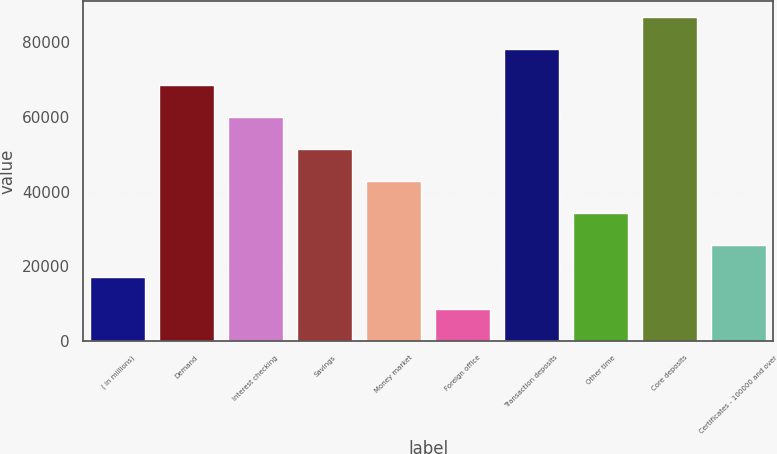Convert chart to OTSL. <chart><loc_0><loc_0><loc_500><loc_500><bar_chart><fcel>( in millions)<fcel>Demand<fcel>Interest checking<fcel>Savings<fcel>Money market<fcel>Foreign office<fcel>Transaction deposits<fcel>Other time<fcel>Core deposits<fcel>Certificates - 100000 and over<nl><fcel>17131.8<fcel>68446.2<fcel>59893.8<fcel>51341.4<fcel>42789<fcel>8579.4<fcel>78116<fcel>34236.6<fcel>86668.4<fcel>25684.2<nl></chart> 